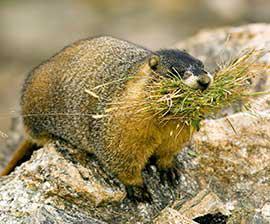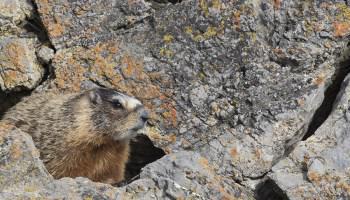The first image is the image on the left, the second image is the image on the right. Given the left and right images, does the statement "Two marmots are facing in opposite directions" hold true? Answer yes or no. No. The first image is the image on the left, the second image is the image on the right. For the images displayed, is the sentence "A marmot is emerging from a crevice, with rocks above and below the animal." factually correct? Answer yes or no. Yes. The first image is the image on the left, the second image is the image on the right. Analyze the images presented: Is the assertion "One of the animals is facing towards the left." valid? Answer yes or no. No. The first image is the image on the left, the second image is the image on the right. Examine the images to the left and right. Is the description "The rodent in the right image is looking towards the right." accurate? Answer yes or no. Yes. 